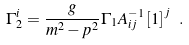Convert formula to latex. <formula><loc_0><loc_0><loc_500><loc_500>\Gamma _ { 2 } ^ { i } = \frac { g } { m ^ { 2 } - p ^ { 2 } } \Gamma _ { 1 } A _ { i j } ^ { - 1 } \left [ 1 \right ] ^ { j } \ .</formula> 